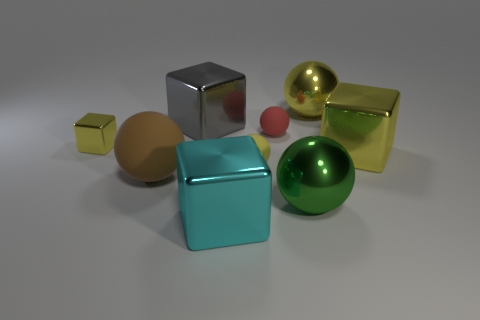What shape is the small matte thing that is the same color as the tiny cube?
Provide a short and direct response. Sphere. Are there more green spheres left of the yellow matte object than yellow metallic objects that are left of the cyan shiny thing?
Offer a terse response. No. Are the object to the left of the big brown sphere and the yellow sphere that is in front of the large gray block made of the same material?
Offer a very short reply. No. Are there any big gray objects in front of the red object?
Your response must be concise. No. How many green things are big metallic objects or spheres?
Offer a terse response. 1. Does the gray thing have the same material as the small object in front of the tiny yellow cube?
Offer a terse response. No. The yellow matte object that is the same shape as the tiny red thing is what size?
Keep it short and to the point. Small. What is the tiny yellow cube made of?
Offer a very short reply. Metal. There is a yellow block that is left of the large metal block on the right side of the shiny ball behind the tiny yellow matte object; what is its material?
Keep it short and to the point. Metal. Is the size of the brown object that is in front of the large gray metallic block the same as the yellow thing to the right of the yellow metal ball?
Ensure brevity in your answer.  Yes. 